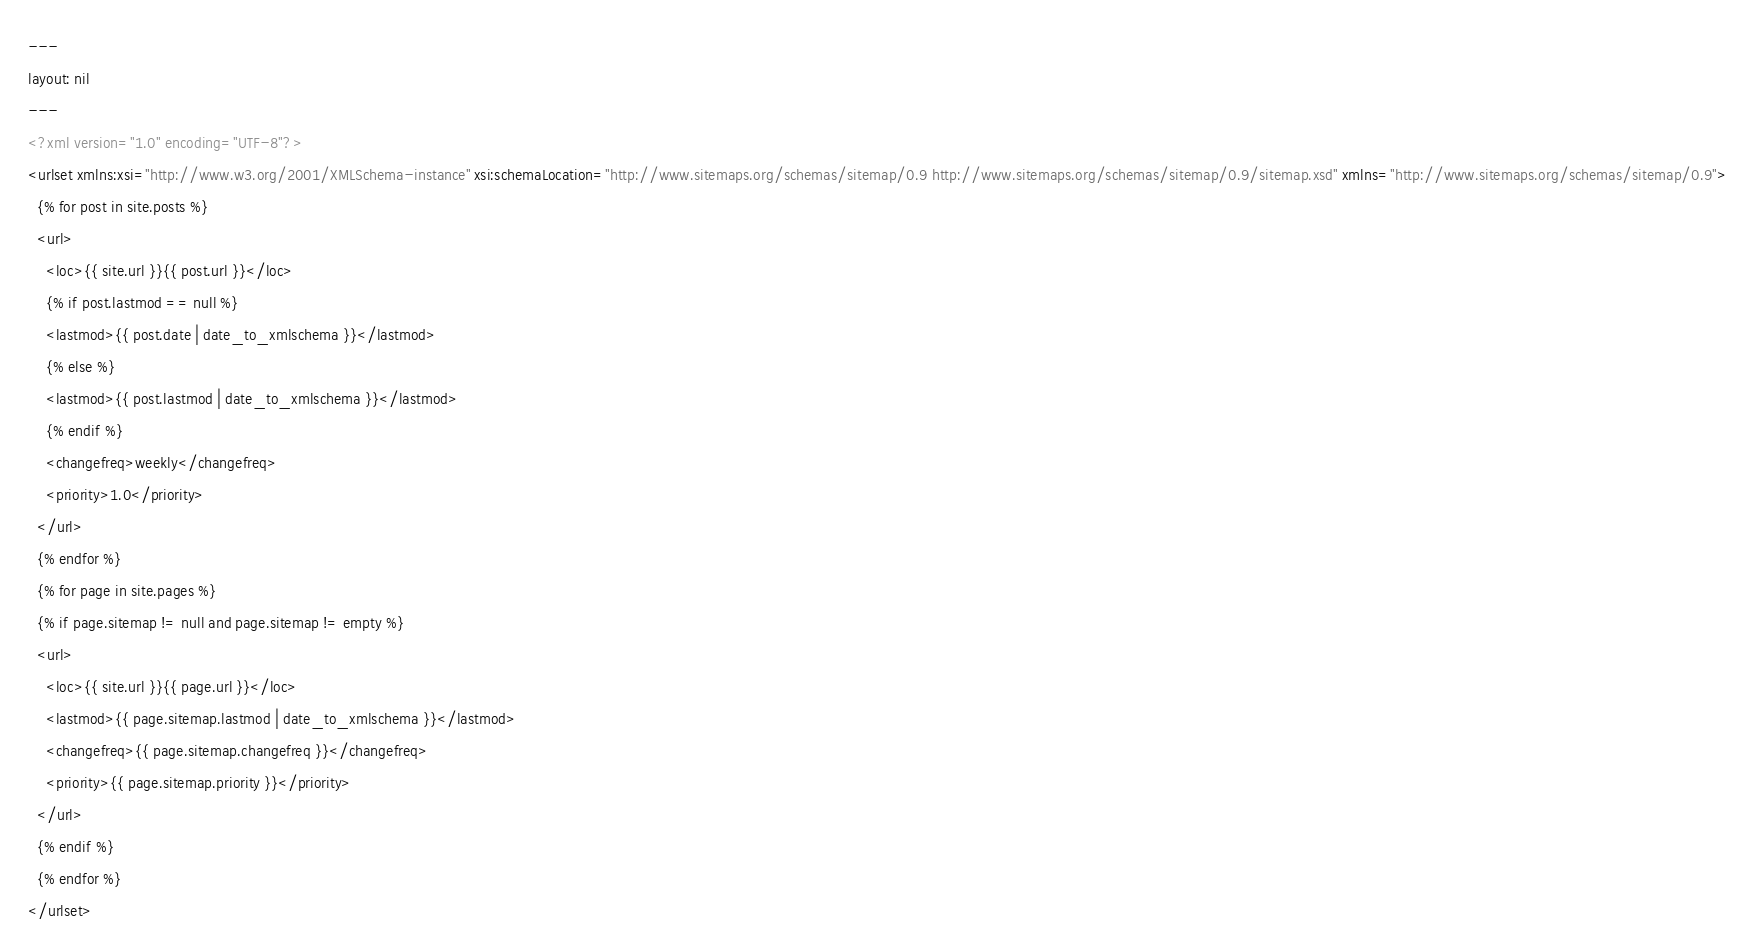<code> <loc_0><loc_0><loc_500><loc_500><_XML_>---
layout: nil
---
<?xml version="1.0" encoding="UTF-8"?>
<urlset xmlns:xsi="http://www.w3.org/2001/XMLSchema-instance" xsi:schemaLocation="http://www.sitemaps.org/schemas/sitemap/0.9 http://www.sitemaps.org/schemas/sitemap/0.9/sitemap.xsd" xmlns="http://www.sitemaps.org/schemas/sitemap/0.9">
  {% for post in site.posts %}
  <url>
    <loc>{{ site.url }}{{ post.url }}</loc>
    {% if post.lastmod == null %}
    <lastmod>{{ post.date | date_to_xmlschema }}</lastmod>
    {% else %}
    <lastmod>{{ post.lastmod | date_to_xmlschema }}</lastmod>
    {% endif %}
    <changefreq>weekly</changefreq>
    <priority>1.0</priority>
  </url>
  {% endfor %}
  {% for page in site.pages %}
  {% if page.sitemap != null and page.sitemap != empty %}
  <url>
    <loc>{{ site.url }}{{ page.url }}</loc>
    <lastmod>{{ page.sitemap.lastmod | date_to_xmlschema }}</lastmod>
    <changefreq>{{ page.sitemap.changefreq }}</changefreq>
    <priority>{{ page.sitemap.priority }}</priority>
  </url>
  {% endif %}
  {% endfor %}
</urlset></code> 